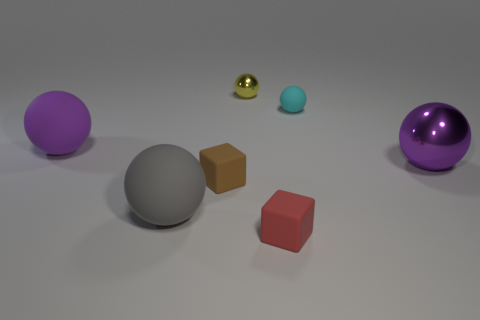What size is the thing that is the same color as the big metal ball?
Provide a short and direct response. Large. There is a tiny rubber thing that is in front of the rubber sphere in front of the big purple thing to the right of the yellow metallic thing; what is its shape?
Provide a succinct answer. Cube. Are there fewer shiny things that are to the left of the brown cube than tiny gray rubber balls?
Ensure brevity in your answer.  No. There is a object that is the same color as the big metallic ball; what is its shape?
Your answer should be very brief. Sphere. How many blue metallic cylinders have the same size as the brown thing?
Offer a very short reply. 0. The tiny brown object left of the small cyan rubber sphere has what shape?
Give a very brief answer. Cube. Is the number of tiny yellow rubber spheres less than the number of large purple matte objects?
Provide a succinct answer. Yes. Is there anything else of the same color as the big metallic thing?
Give a very brief answer. Yes. There is a ball to the left of the large gray ball; what size is it?
Keep it short and to the point. Large. Is the number of purple cubes greater than the number of tiny matte spheres?
Your answer should be compact. No. 